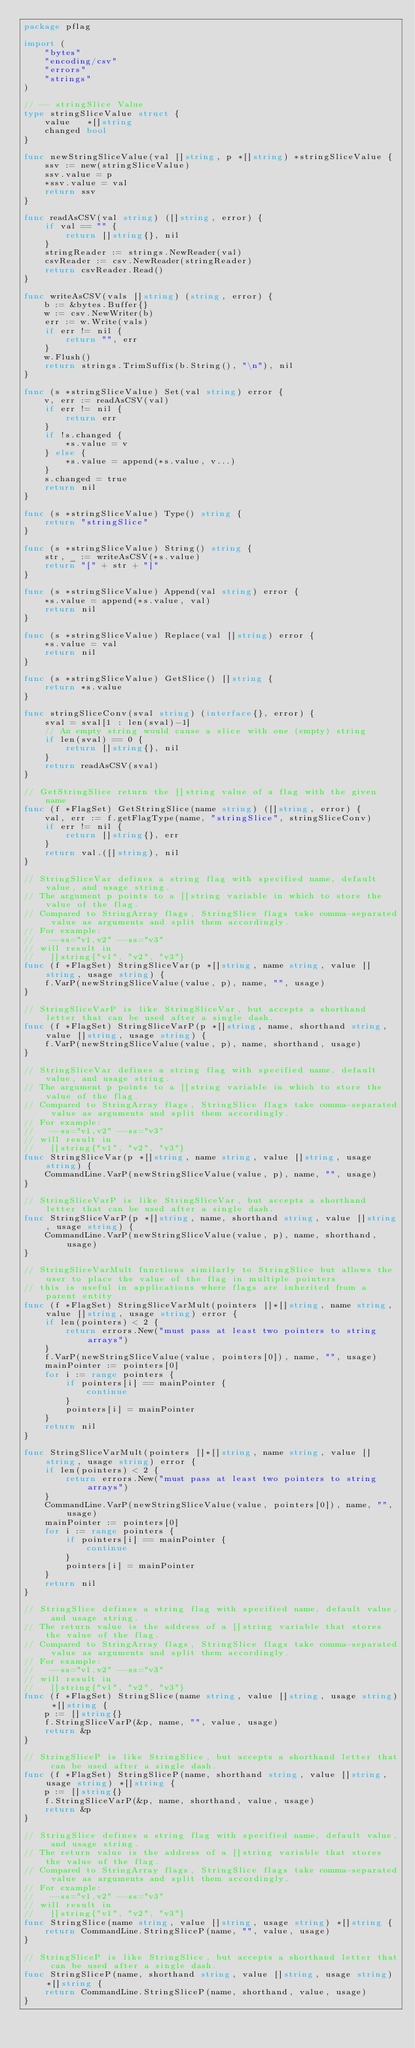Convert code to text. <code><loc_0><loc_0><loc_500><loc_500><_Go_>package pflag

import (
	"bytes"
	"encoding/csv"
	"errors"
	"strings"
)

// -- stringSlice Value
type stringSliceValue struct {
	value   *[]string
	changed bool
}

func newStringSliceValue(val []string, p *[]string) *stringSliceValue {
	ssv := new(stringSliceValue)
	ssv.value = p
	*ssv.value = val
	return ssv
}

func readAsCSV(val string) ([]string, error) {
	if val == "" {
		return []string{}, nil
	}
	stringReader := strings.NewReader(val)
	csvReader := csv.NewReader(stringReader)
	return csvReader.Read()
}

func writeAsCSV(vals []string) (string, error) {
	b := &bytes.Buffer{}
	w := csv.NewWriter(b)
	err := w.Write(vals)
	if err != nil {
		return "", err
	}
	w.Flush()
	return strings.TrimSuffix(b.String(), "\n"), nil
}

func (s *stringSliceValue) Set(val string) error {
	v, err := readAsCSV(val)
	if err != nil {
		return err
	}
	if !s.changed {
		*s.value = v
	} else {
		*s.value = append(*s.value, v...)
	}
	s.changed = true
	return nil
}

func (s *stringSliceValue) Type() string {
	return "stringSlice"
}

func (s *stringSliceValue) String() string {
	str, _ := writeAsCSV(*s.value)
	return "[" + str + "]"
}

func (s *stringSliceValue) Append(val string) error {
	*s.value = append(*s.value, val)
	return nil
}

func (s *stringSliceValue) Replace(val []string) error {
	*s.value = val
	return nil
}

func (s *stringSliceValue) GetSlice() []string {
	return *s.value
}

func stringSliceConv(sval string) (interface{}, error) {
	sval = sval[1 : len(sval)-1]
	// An empty string would cause a slice with one (empty) string
	if len(sval) == 0 {
		return []string{}, nil
	}
	return readAsCSV(sval)
}

// GetStringSlice return the []string value of a flag with the given name
func (f *FlagSet) GetStringSlice(name string) ([]string, error) {
	val, err := f.getFlagType(name, "stringSlice", stringSliceConv)
	if err != nil {
		return []string{}, err
	}
	return val.([]string), nil
}

// StringSliceVar defines a string flag with specified name, default value, and usage string.
// The argument p points to a []string variable in which to store the value of the flag.
// Compared to StringArray flags, StringSlice flags take comma-separated value as arguments and split them accordingly.
// For example:
//   --ss="v1,v2" --ss="v3"
// will result in
//   []string{"v1", "v2", "v3"}
func (f *FlagSet) StringSliceVar(p *[]string, name string, value []string, usage string) {
	f.VarP(newStringSliceValue(value, p), name, "", usage)
}

// StringSliceVarP is like StringSliceVar, but accepts a shorthand letter that can be used after a single dash.
func (f *FlagSet) StringSliceVarP(p *[]string, name, shorthand string, value []string, usage string) {
	f.VarP(newStringSliceValue(value, p), name, shorthand, usage)
}

// StringSliceVar defines a string flag with specified name, default value, and usage string.
// The argument p points to a []string variable in which to store the value of the flag.
// Compared to StringArray flags, StringSlice flags take comma-separated value as arguments and split them accordingly.
// For example:
//   --ss="v1,v2" --ss="v3"
// will result in
//   []string{"v1", "v2", "v3"}
func StringSliceVar(p *[]string, name string, value []string, usage string) {
	CommandLine.VarP(newStringSliceValue(value, p), name, "", usage)
}

// StringSliceVarP is like StringSliceVar, but accepts a shorthand letter that can be used after a single dash.
func StringSliceVarP(p *[]string, name, shorthand string, value []string, usage string) {
	CommandLine.VarP(newStringSliceValue(value, p), name, shorthand, usage)
}

// StringSliceVarMult functions similarly to StringSlice but allows the user to place the value of the flag in multiple pointers
// this is useful in applications where flags are inherited from a parent entity
func (f *FlagSet) StringSliceVarMult(pointers []*[]string, name string, value []string, usage string) error {
	if len(pointers) < 2 {
		return errors.New("must pass at least two pointers to string arrays")
	}
	f.VarP(newStringSliceValue(value, pointers[0]), name, "", usage)
	mainPointer := pointers[0]
	for i := range pointers {
		if pointers[i] == mainPointer {
			continue
		}
		pointers[i] = mainPointer
	}
	return nil
}

func StringSliceVarMult(pointers []*[]string, name string, value []string, usage string) error {
	if len(pointers) < 2 {
		return errors.New("must pass at least two pointers to string arrays")
	}
	CommandLine.VarP(newStringSliceValue(value, pointers[0]), name, "", usage)
	mainPointer := pointers[0]
	for i := range pointers {
		if pointers[i] == mainPointer {
			continue
		}
		pointers[i] = mainPointer
	}
	return nil
}

// StringSlice defines a string flag with specified name, default value, and usage string.
// The return value is the address of a []string variable that stores the value of the flag.
// Compared to StringArray flags, StringSlice flags take comma-separated value as arguments and split them accordingly.
// For example:
//   --ss="v1,v2" --ss="v3"
// will result in
//   []string{"v1", "v2", "v3"}
func (f *FlagSet) StringSlice(name string, value []string, usage string) *[]string {
	p := []string{}
	f.StringSliceVarP(&p, name, "", value, usage)
	return &p
}

// StringSliceP is like StringSlice, but accepts a shorthand letter that can be used after a single dash.
func (f *FlagSet) StringSliceP(name, shorthand string, value []string, usage string) *[]string {
	p := []string{}
	f.StringSliceVarP(&p, name, shorthand, value, usage)
	return &p
}

// StringSlice defines a string flag with specified name, default value, and usage string.
// The return value is the address of a []string variable that stores the value of the flag.
// Compared to StringArray flags, StringSlice flags take comma-separated value as arguments and split them accordingly.
// For example:
//   --ss="v1,v2" --ss="v3"
// will result in
//   []string{"v1", "v2", "v3"}
func StringSlice(name string, value []string, usage string) *[]string {
	return CommandLine.StringSliceP(name, "", value, usage)
}

// StringSliceP is like StringSlice, but accepts a shorthand letter that can be used after a single dash.
func StringSliceP(name, shorthand string, value []string, usage string) *[]string {
	return CommandLine.StringSliceP(name, shorthand, value, usage)
}
</code> 